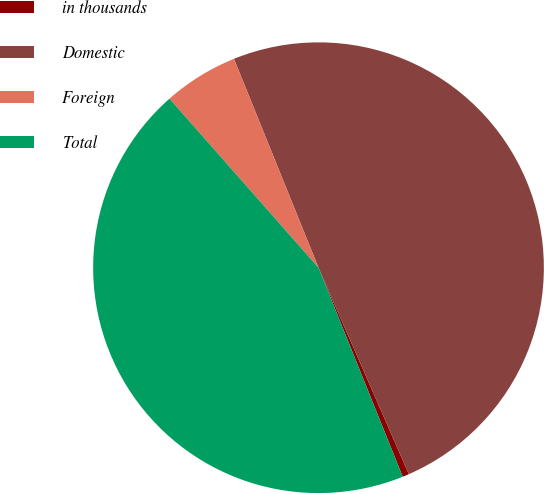<chart> <loc_0><loc_0><loc_500><loc_500><pie_chart><fcel>in thousands<fcel>Domestic<fcel>Foreign<fcel>Total<nl><fcel>0.47%<fcel>49.56%<fcel>5.38%<fcel>44.6%<nl></chart> 